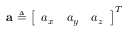<formula> <loc_0><loc_0><loc_500><loc_500>a \triangle q \left [ \begin{array} { l l l } { a _ { x } } & { a _ { y } } & { a _ { z } } \end{array} \right ] ^ { T }</formula> 